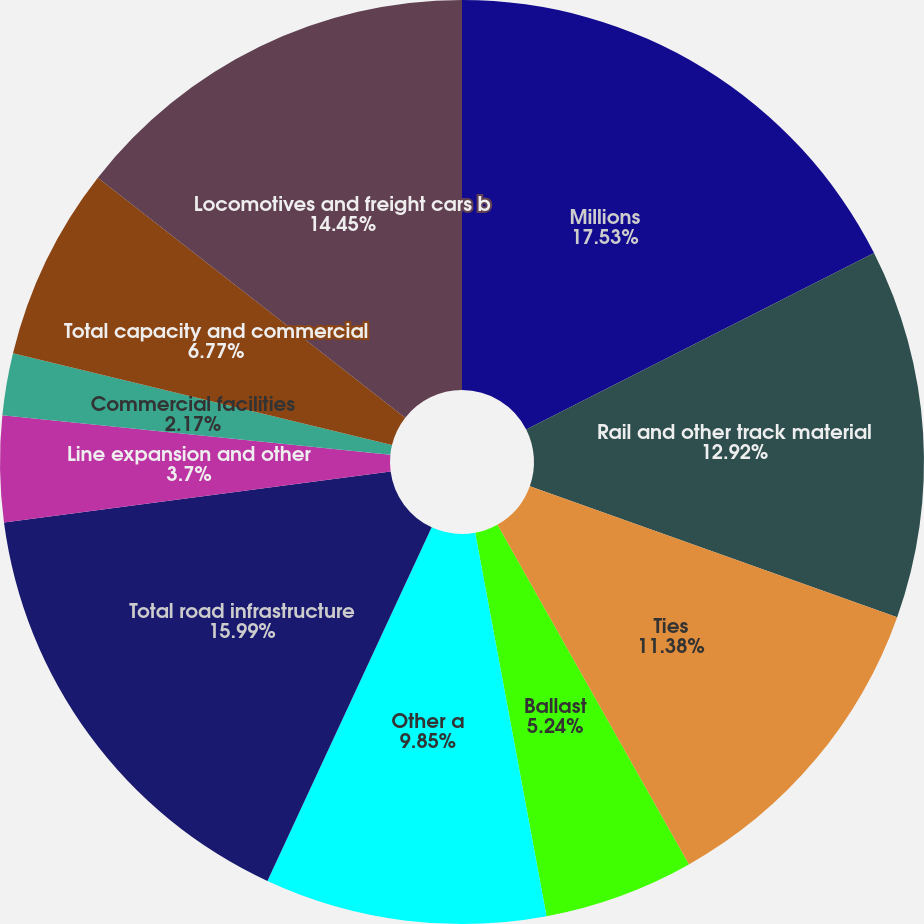Convert chart. <chart><loc_0><loc_0><loc_500><loc_500><pie_chart><fcel>Millions<fcel>Rail and other track material<fcel>Ties<fcel>Ballast<fcel>Other a<fcel>Total road infrastructure<fcel>Line expansion and other<fcel>Commercial facilities<fcel>Total capacity and commercial<fcel>Locomotives and freight cars b<nl><fcel>17.53%<fcel>12.92%<fcel>11.38%<fcel>5.24%<fcel>9.85%<fcel>15.99%<fcel>3.7%<fcel>2.17%<fcel>6.77%<fcel>14.45%<nl></chart> 